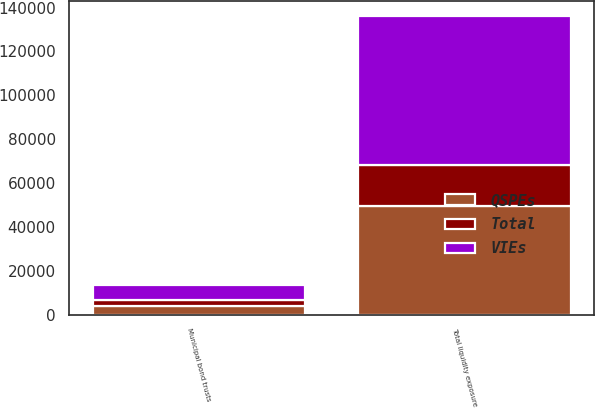Convert chart. <chart><loc_0><loc_0><loc_500><loc_500><stacked_bar_chart><ecel><fcel>Municipal bond trusts<fcel>Total liquidity exposure<nl><fcel>QSPEs<fcel>3872<fcel>49651<nl><fcel>Total<fcel>2921<fcel>18509<nl><fcel>VIEs<fcel>6793<fcel>68160<nl></chart> 